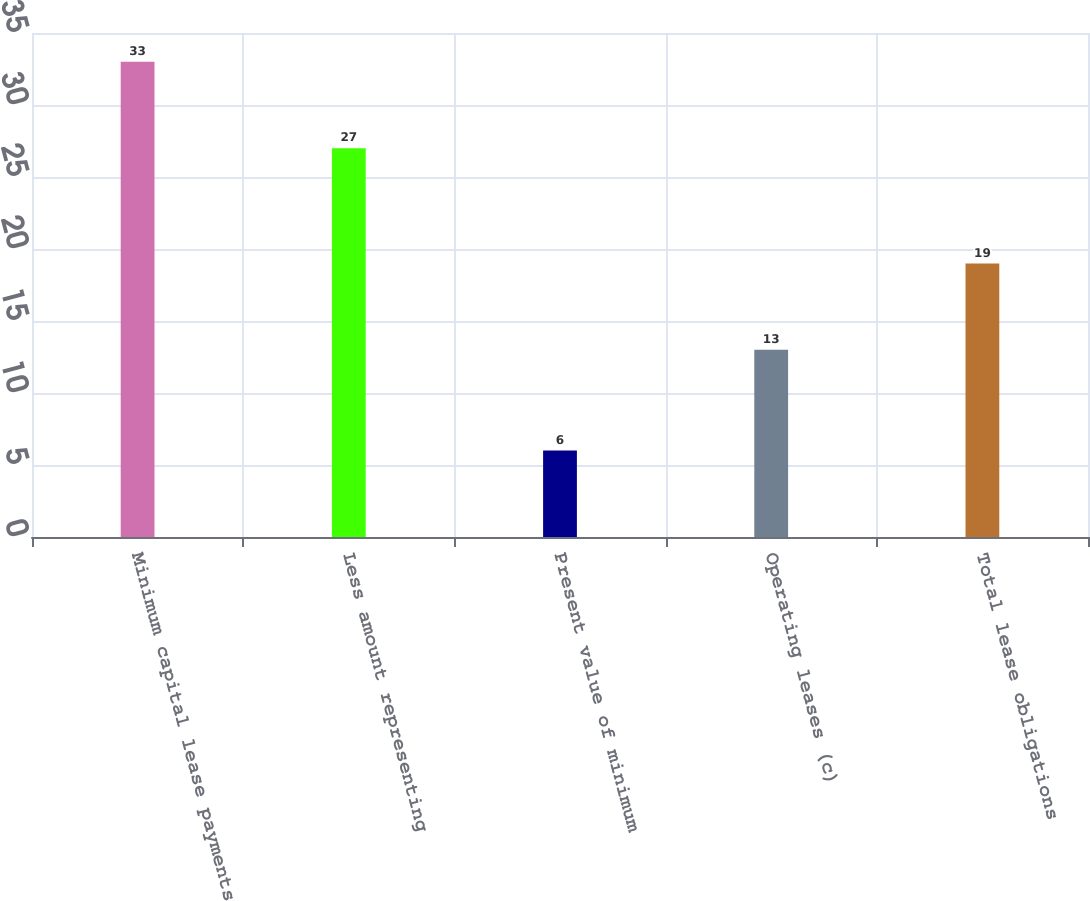<chart> <loc_0><loc_0><loc_500><loc_500><bar_chart><fcel>Minimum capital lease payments<fcel>Less amount representing<fcel>Present value of minimum<fcel>Operating leases (c)<fcel>Total lease obligations<nl><fcel>33<fcel>27<fcel>6<fcel>13<fcel>19<nl></chart> 